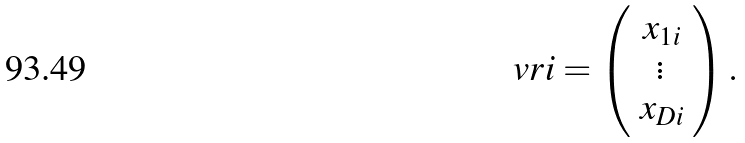<formula> <loc_0><loc_0><loc_500><loc_500>\ v r i = \left ( \begin{array} { c } x _ { 1 i } \\ \vdots \\ x _ { D i } \end{array} \right ) .</formula> 